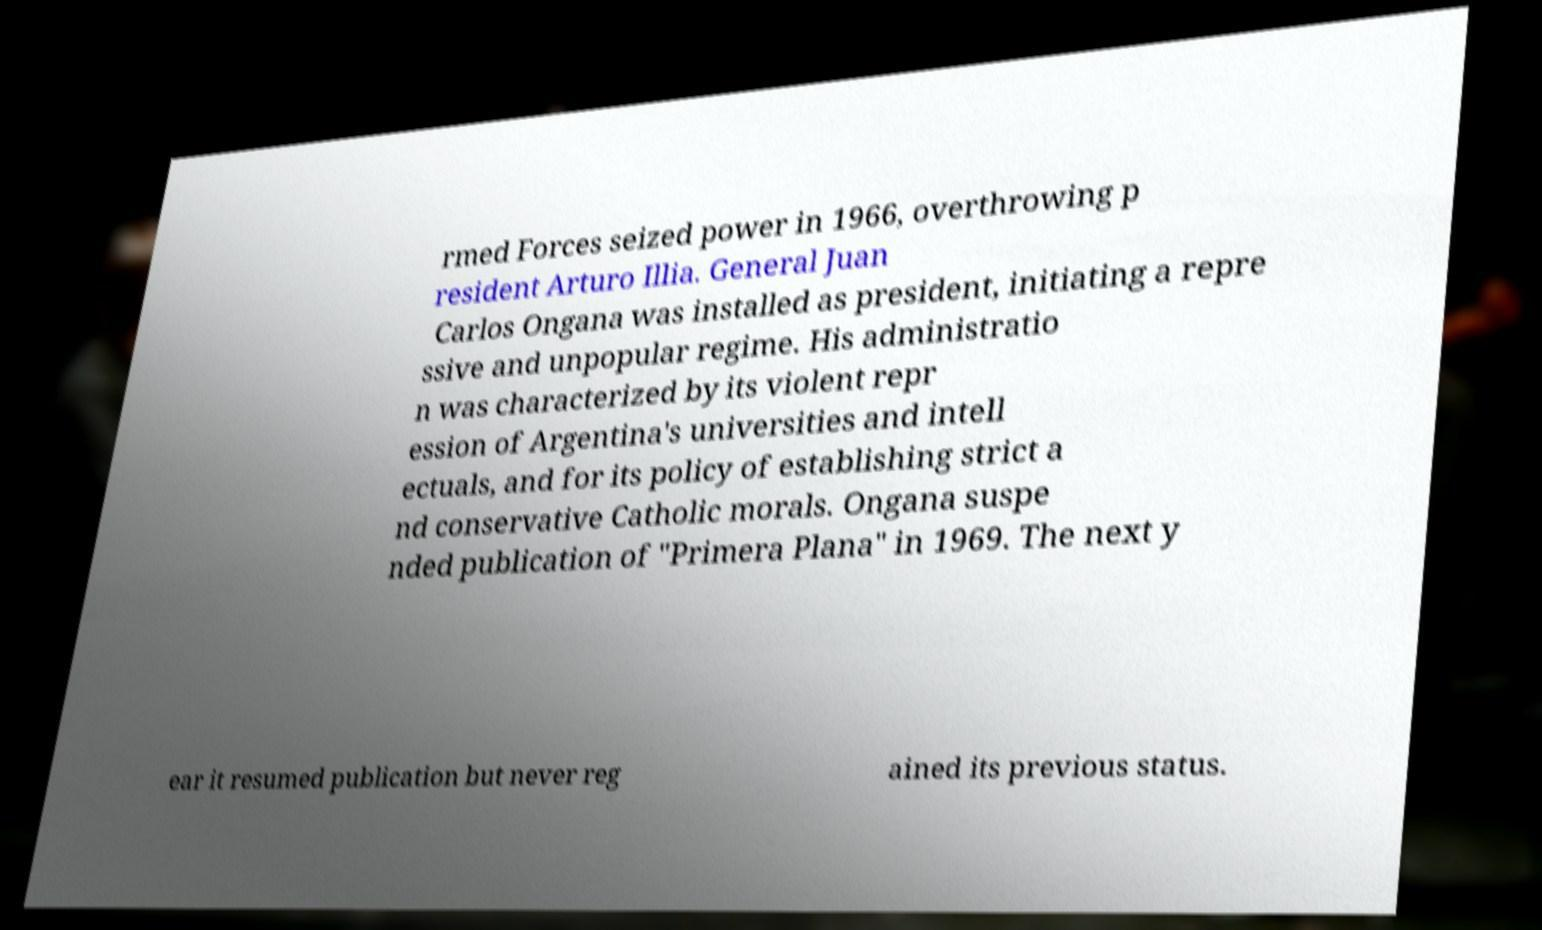Please read and relay the text visible in this image. What does it say? rmed Forces seized power in 1966, overthrowing p resident Arturo Illia. General Juan Carlos Ongana was installed as president, initiating a repre ssive and unpopular regime. His administratio n was characterized by its violent repr ession of Argentina's universities and intell ectuals, and for its policy of establishing strict a nd conservative Catholic morals. Ongana suspe nded publication of "Primera Plana" in 1969. The next y ear it resumed publication but never reg ained its previous status. 